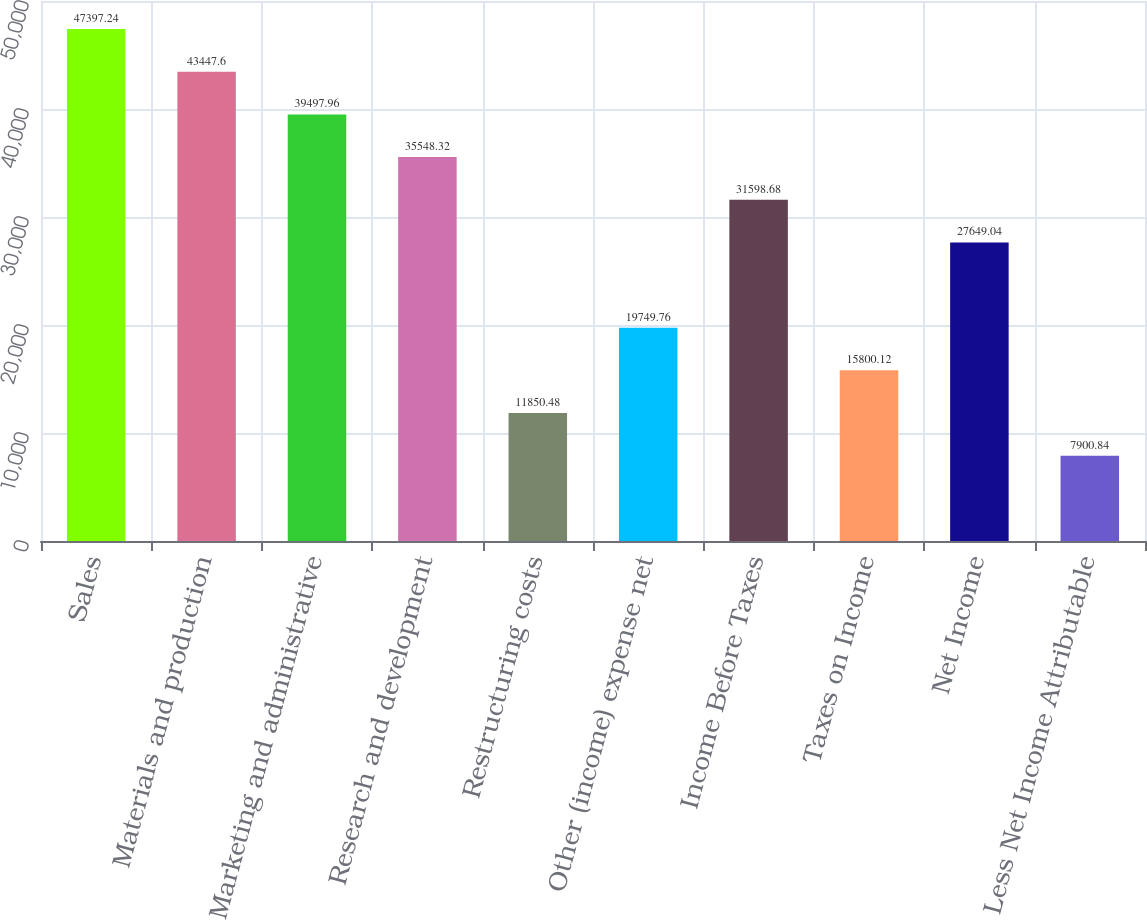Convert chart. <chart><loc_0><loc_0><loc_500><loc_500><bar_chart><fcel>Sales<fcel>Materials and production<fcel>Marketing and administrative<fcel>Research and development<fcel>Restructuring costs<fcel>Other (income) expense net<fcel>Income Before Taxes<fcel>Taxes on Income<fcel>Net Income<fcel>Less Net Income Attributable<nl><fcel>47397.2<fcel>43447.6<fcel>39498<fcel>35548.3<fcel>11850.5<fcel>19749.8<fcel>31598.7<fcel>15800.1<fcel>27649<fcel>7900.84<nl></chart> 